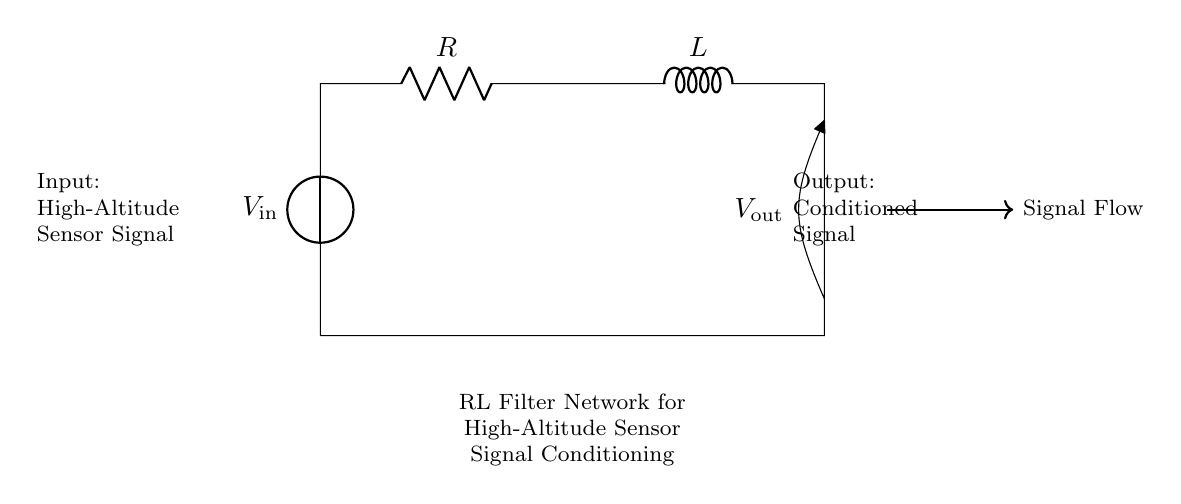What is the input voltage source in the circuit? The input voltage source is labeled as V_in, which is located at the left side of the circuit, providing the input signal to the filter network.
Answer: V_in What are the two primary components in this RL filter network? The primary components are labeled as R for the resistor and L for the inductor, which together form the filter network.
Answer: Resistor and Inductor What is the output of this circuit labeled as? The output of the circuit is labeled as V_out, which is located at the right side of the inductor and indicates the conditioned output signal.
Answer: V_out Which component dominates the behavior of the circuit at high frequencies? The inductor L dominates the behavior at high frequencies due to its property of opposing changes in current, resulting in a higher impedance.
Answer: Inductor How does this RL filter affect the sensor signal? The RL filter conditions the input signal by attenuating higher frequency noise and allowing lower frequency signals, effectively smoothing the signal output.
Answer: Attenuates high frequencies What is the role of the resistor in this circuit? The resistor R limits the current flow in the circuit and also plays a role in the voltage drop across the circuit, affecting the overall impedance of the filter network.
Answer: Limits current flow What happens to the output signal if resistance is increased? Increasing the resistance R would lower the output voltage due to increased voltage drop across the resistor, which can lead to reduced signal conditioning effectiveness.
Answer: Output voltage decreases 